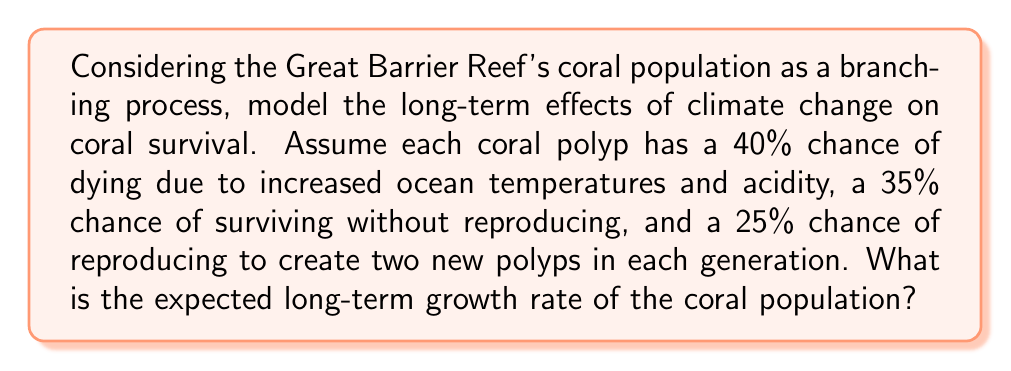Give your solution to this math problem. To solve this problem, we'll use the theory of branching processes:

1) First, let's define our probability generating function (PGF):
   $$f(s) = 0.40 + 0.35s + 0.25s^2$$

2) The expected number of offspring per individual, $m$, is given by $f'(1)$:
   $$f'(s) = 0.35 + 0.50s$$
   $$m = f'(1) = 0.35 + 0.50 = 0.85$$

3) In a branching process, the long-term behavior depends on $m$:
   - If $m < 1$, the population will eventually die out.
   - If $m > 1$, the population will grow exponentially.
   - If $m = 1$, the population size will remain stable on average.

4) In this case, $m = 0.85 < 1$, indicating that the population will eventually die out.

5) The long-term growth rate, $r$, is given by:
   $$r = m - 1 = 0.85 - 1 = -0.15$$

This negative growth rate indicates that the coral population is expected to decline by 15% each generation under these climate change conditions.
Answer: $-0.15$ or $-15\%$ per generation 